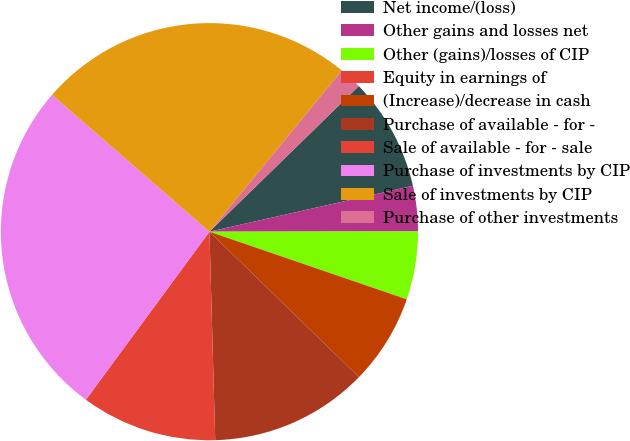Convert chart to OTSL. <chart><loc_0><loc_0><loc_500><loc_500><pie_chart><fcel>Net income/(loss)<fcel>Other gains and losses net<fcel>Other (gains)/losses of CIP<fcel>Equity in earnings of<fcel>(Increase)/decrease in cash<fcel>Purchase of available - for -<fcel>Sale of available - for - sale<fcel>Purchase of investments by CIP<fcel>Sale of investments by CIP<fcel>Purchase of other investments<nl><fcel>8.77%<fcel>3.51%<fcel>5.27%<fcel>0.01%<fcel>7.02%<fcel>12.28%<fcel>10.53%<fcel>26.3%<fcel>24.55%<fcel>1.76%<nl></chart> 